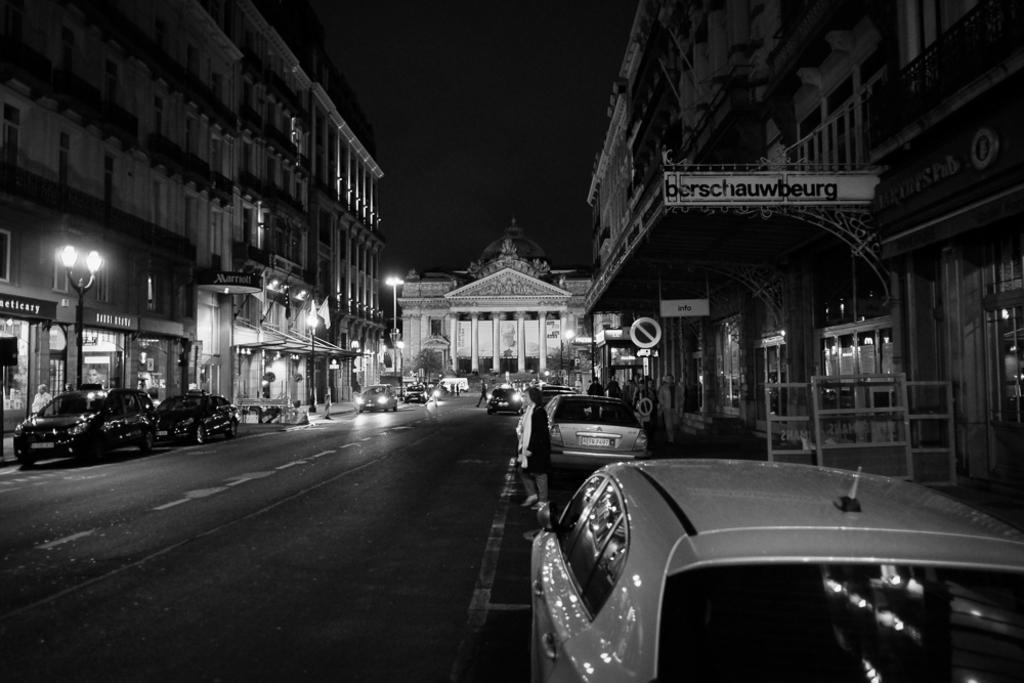Can you describe this image briefly? In this image we can see group of cars parked on the road. Several persons are walking on the path. In the background we can see group of buildings ,poles ,lights and sky. 